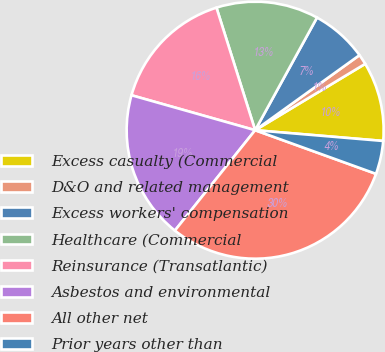Convert chart. <chart><loc_0><loc_0><loc_500><loc_500><pie_chart><fcel>Excess casualty (Commercial<fcel>D&O and related management<fcel>Excess workers' compensation<fcel>Healthcare (Commercial<fcel>Reinsurance (Transatlantic)<fcel>Asbestos and environmental<fcel>All other net<fcel>Prior years other than<nl><fcel>9.97%<fcel>1.29%<fcel>7.08%<fcel>12.86%<fcel>15.75%<fcel>18.65%<fcel>30.22%<fcel>4.18%<nl></chart> 